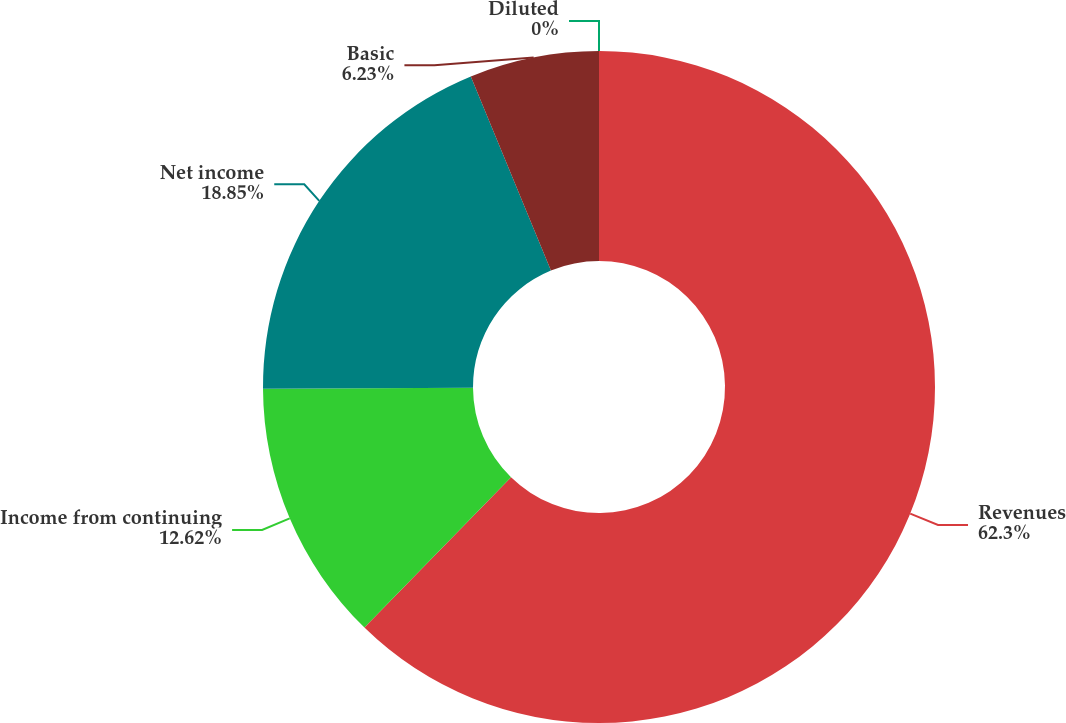Convert chart. <chart><loc_0><loc_0><loc_500><loc_500><pie_chart><fcel>Revenues<fcel>Income from continuing<fcel>Net income<fcel>Basic<fcel>Diluted<nl><fcel>62.3%<fcel>12.62%<fcel>18.85%<fcel>6.23%<fcel>0.0%<nl></chart> 